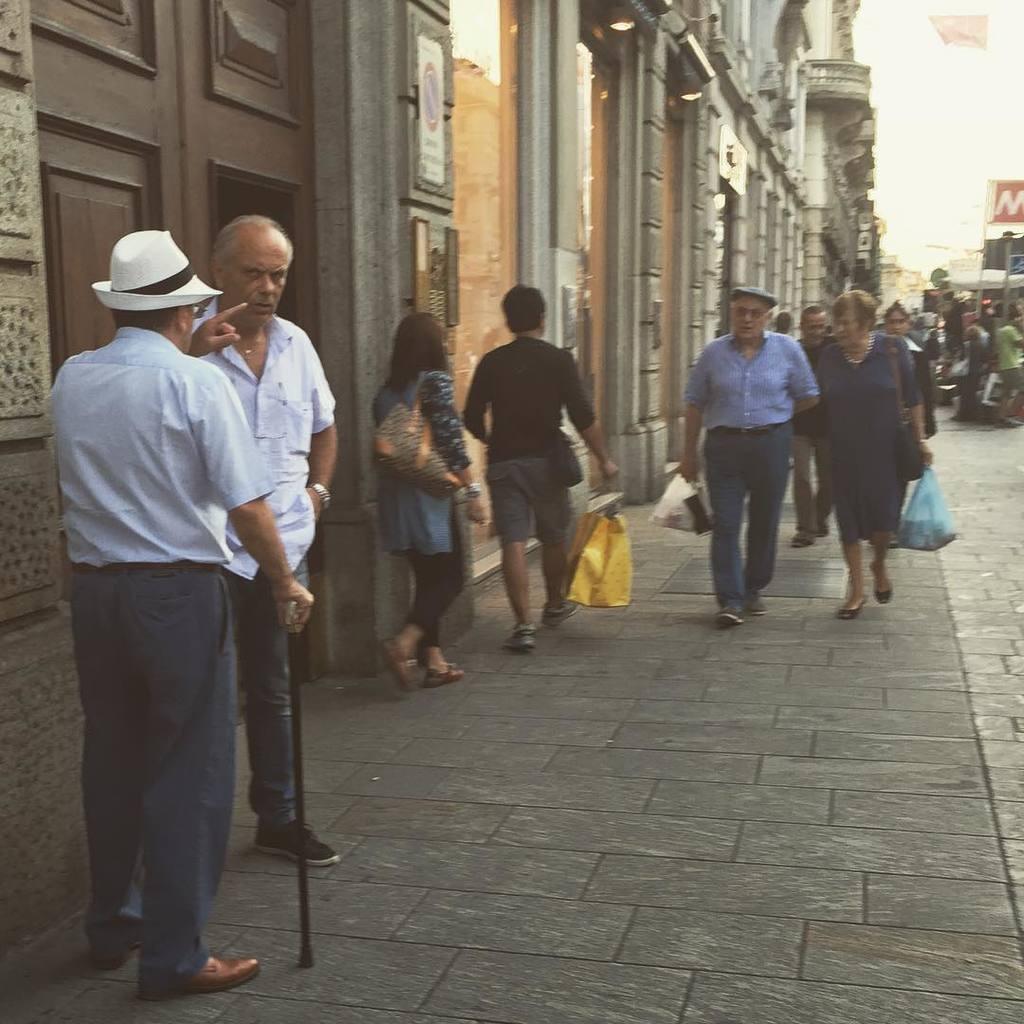Please provide a concise description of this image. In this image we can a few people, among them some holding objects and on the left side, we can see some buildings with doors and a poster with text. 